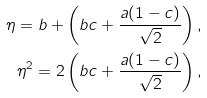Convert formula to latex. <formula><loc_0><loc_0><loc_500><loc_500>\eta = b + \left ( b c + \frac { a ( 1 - c ) } { \sqrt { 2 } } \right ) , \\ \eta ^ { 2 } = 2 \left ( b c + \frac { a ( 1 - c ) } { \sqrt { 2 } } \right ) ,</formula> 